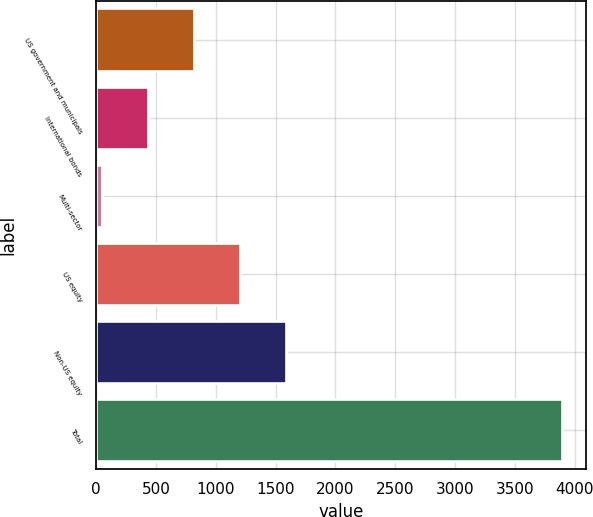<chart> <loc_0><loc_0><loc_500><loc_500><bar_chart><fcel>US government and municipals<fcel>International bonds<fcel>Multi-sector<fcel>US equity<fcel>Non-US equity<fcel>Total<nl><fcel>820.6<fcel>436.3<fcel>52<fcel>1204.9<fcel>1589.2<fcel>3895<nl></chart> 